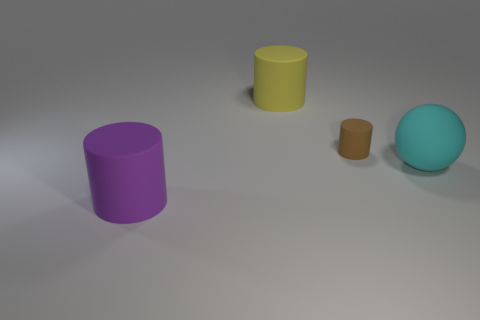Add 3 small rubber cubes. How many objects exist? 7 Subtract all spheres. How many objects are left? 3 Add 4 big things. How many big things are left? 7 Add 3 large matte cylinders. How many large matte cylinders exist? 5 Subtract 0 purple blocks. How many objects are left? 4 Subtract all tiny rubber things. Subtract all big blue cubes. How many objects are left? 3 